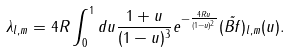<formula> <loc_0><loc_0><loc_500><loc_500>\lambda _ { l , m } = 4 R \int _ { 0 } ^ { 1 } d u \frac { 1 + u } { ( 1 - u ) ^ { 3 } } e ^ { - \frac { 4 R u } { ( 1 - u ) ^ { 2 } } } ( \tilde { B f } ) _ { l , m } ( u ) .</formula> 